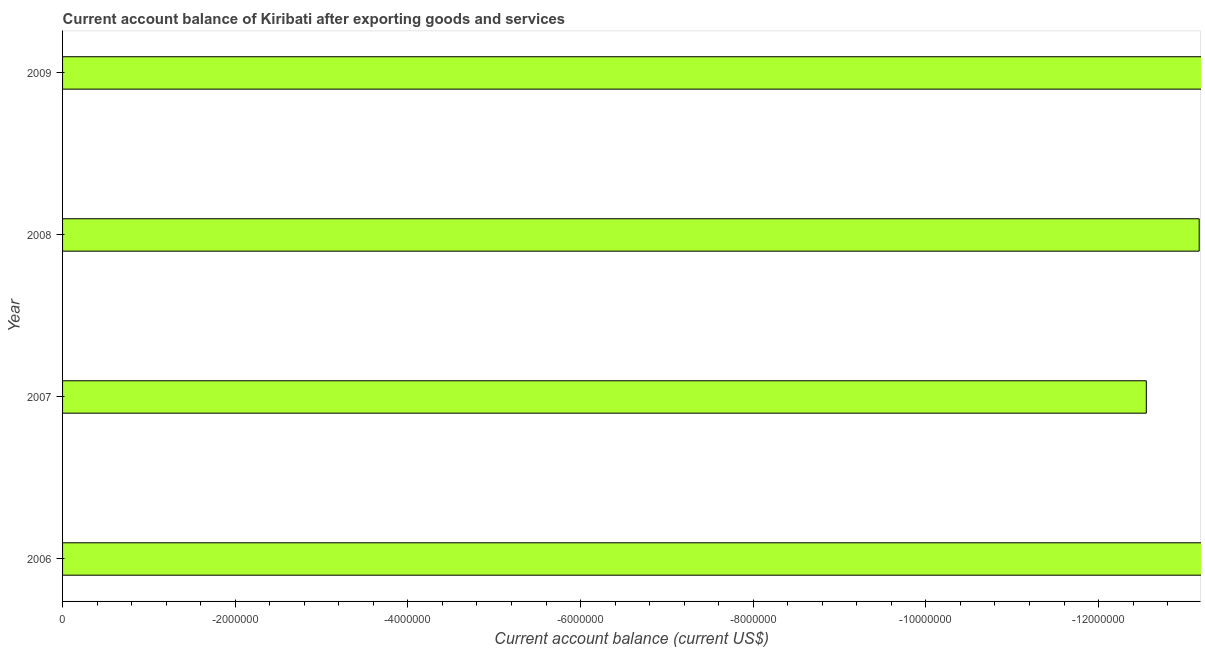Does the graph contain any zero values?
Offer a very short reply. Yes. Does the graph contain grids?
Keep it short and to the point. No. What is the title of the graph?
Offer a very short reply. Current account balance of Kiribati after exporting goods and services. What is the label or title of the X-axis?
Your response must be concise. Current account balance (current US$). What is the label or title of the Y-axis?
Keep it short and to the point. Year. What is the current account balance in 2008?
Ensure brevity in your answer.  0. Across all years, what is the minimum current account balance?
Provide a short and direct response. 0. What is the average current account balance per year?
Give a very brief answer. 0. In how many years, is the current account balance greater than the average current account balance taken over all years?
Your answer should be very brief. 0. How many bars are there?
Your answer should be very brief. 0. Are all the bars in the graph horizontal?
Your answer should be very brief. Yes. How many years are there in the graph?
Your answer should be very brief. 4. Are the values on the major ticks of X-axis written in scientific E-notation?
Your answer should be very brief. No. What is the Current account balance (current US$) of 2008?
Your answer should be compact. 0. What is the Current account balance (current US$) of 2009?
Offer a very short reply. 0. 